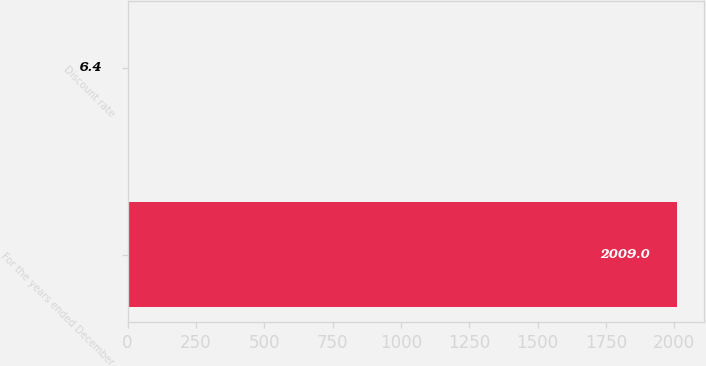<chart> <loc_0><loc_0><loc_500><loc_500><bar_chart><fcel>For the years ended December<fcel>Discount rate<nl><fcel>2009<fcel>6.4<nl></chart> 